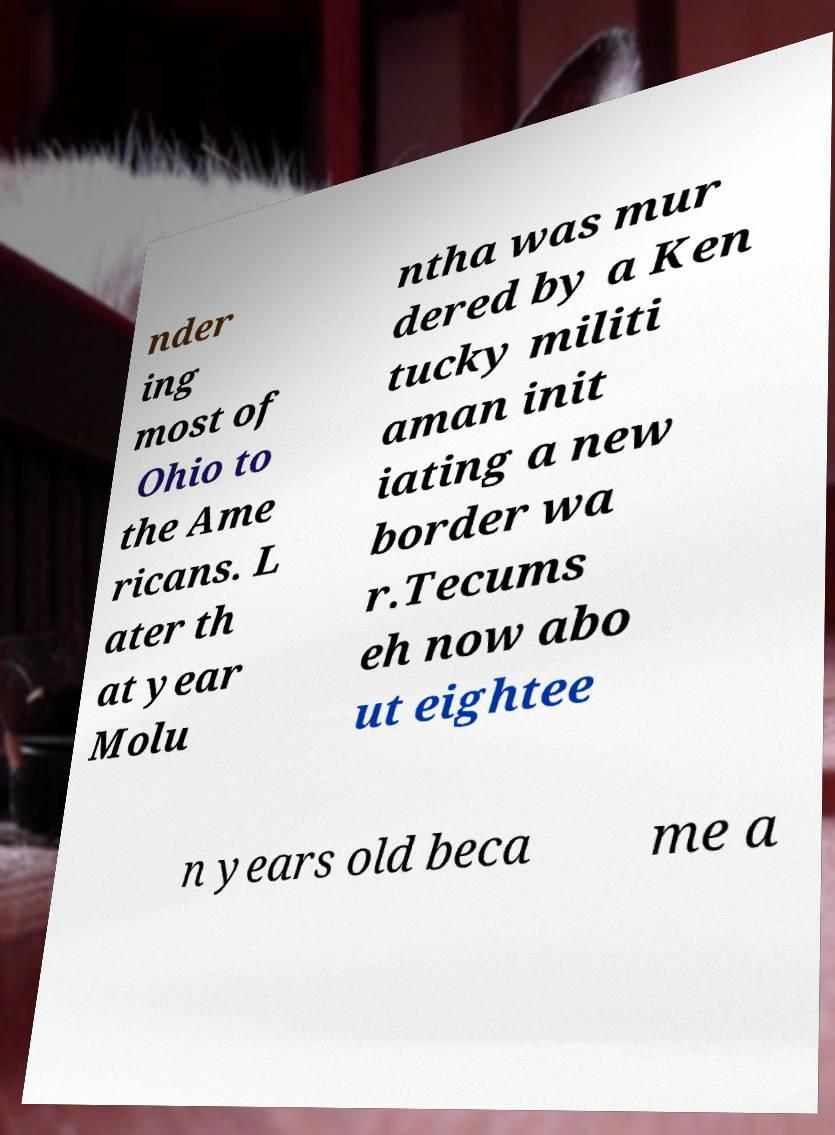Could you assist in decoding the text presented in this image and type it out clearly? nder ing most of Ohio to the Ame ricans. L ater th at year Molu ntha was mur dered by a Ken tucky militi aman init iating a new border wa r.Tecums eh now abo ut eightee n years old beca me a 